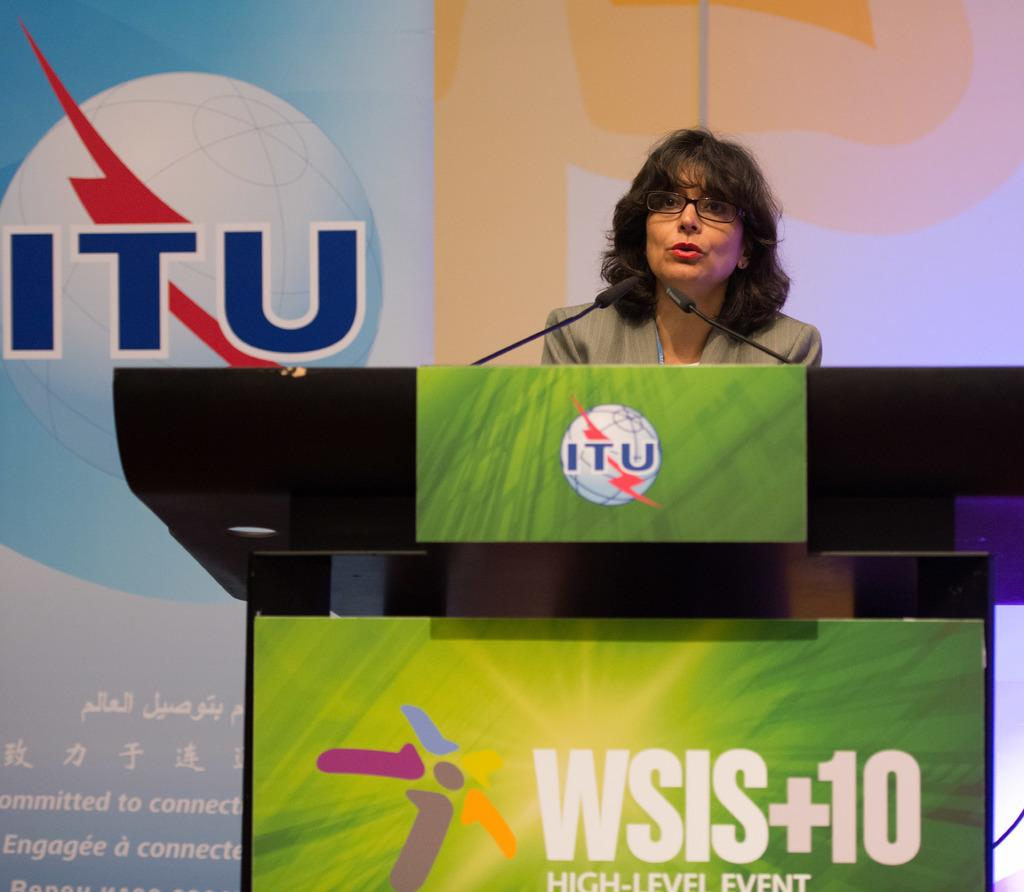Who is the main subject in the image? There is a woman in the image. What other creatures are present in the image? There are mice in the image. What object can be seen in the image that might be used for presentations? There is a podium in the image. What can be seen in the background of the image? A poster is visible in the background of the image. What type of jeans is the woman wearing in the image? There is no information about jeans in the image, as the focus is on the woman, mice, podium, and poster. 